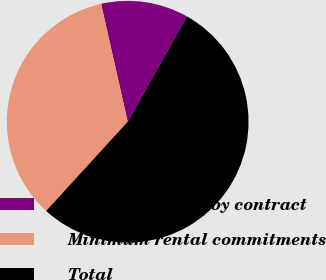<chart> <loc_0><loc_0><loc_500><loc_500><pie_chart><fcel>Debt obligations by contract<fcel>Minimum rental commitments<fcel>Total<nl><fcel>11.69%<fcel>34.68%<fcel>53.62%<nl></chart> 